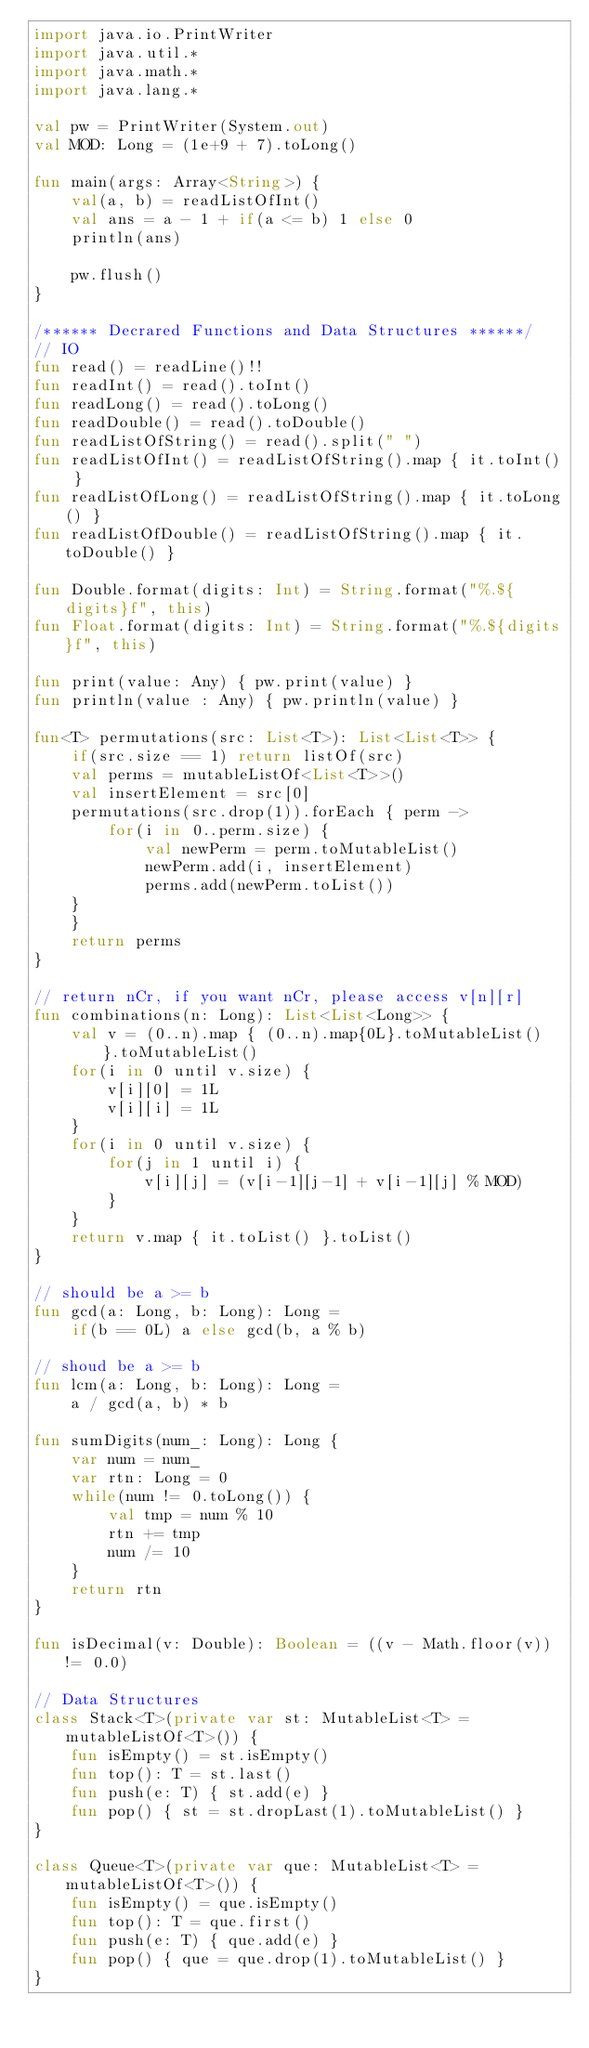Convert code to text. <code><loc_0><loc_0><loc_500><loc_500><_Kotlin_>import java.io.PrintWriter
import java.util.*
import java.math.*
import java.lang.*

val pw = PrintWriter(System.out)
val MOD: Long = (1e+9 + 7).toLong()

fun main(args: Array<String>) {
    val(a, b) = readListOfInt()
    val ans = a - 1 + if(a <= b) 1 else 0
    println(ans)
    
    pw.flush()
}

/****** Decrared Functions and Data Structures ******/
// IO
fun read() = readLine()!!
fun readInt() = read().toInt()
fun readLong() = read().toLong()
fun readDouble() = read().toDouble()
fun readListOfString() = read().split(" ")
fun readListOfInt() = readListOfString().map { it.toInt() }
fun readListOfLong() = readListOfString().map { it.toLong() }
fun readListOfDouble() = readListOfString().map { it.toDouble() }

fun Double.format(digits: Int) = String.format("%.${digits}f", this)
fun Float.format(digits: Int) = String.format("%.${digits}f", this)

fun print(value: Any) { pw.print(value) }
fun println(value : Any) { pw.println(value) }

fun<T> permutations(src: List<T>): List<List<T>> {
    if(src.size == 1) return listOf(src)
    val perms = mutableListOf<List<T>>()
    val insertElement = src[0]
    permutations(src.drop(1)).forEach { perm ->
        for(i in 0..perm.size) {
            val newPerm = perm.toMutableList()
            newPerm.add(i, insertElement)
            perms.add(newPerm.toList())
    }
    }
    return perms
}

// return nCr, if you want nCr, please access v[n][r]
fun combinations(n: Long): List<List<Long>> {
    val v = (0..n).map { (0..n).map{0L}.toMutableList() }.toMutableList()
    for(i in 0 until v.size) {
        v[i][0] = 1L
        v[i][i] = 1L
    }
    for(i in 0 until v.size) {
        for(j in 1 until i) {
            v[i][j] = (v[i-1][j-1] + v[i-1][j] % MOD)
        }
    }
    return v.map { it.toList() }.toList()
}

// should be a >= b
fun gcd(a: Long, b: Long): Long = 
    if(b == 0L) a else gcd(b, a % b)

// shoud be a >= b
fun lcm(a: Long, b: Long): Long = 
    a / gcd(a, b) * b

fun sumDigits(num_: Long): Long {
    var num = num_
    var rtn: Long = 0
    while(num != 0.toLong()) {
        val tmp = num % 10
        rtn += tmp
        num /= 10
    }
    return rtn
}

fun isDecimal(v: Double): Boolean = ((v - Math.floor(v)) != 0.0)

// Data Structures
class Stack<T>(private var st: MutableList<T> = mutableListOf<T>()) {
    fun isEmpty() = st.isEmpty()
    fun top(): T = st.last()
    fun push(e: T) { st.add(e) }
    fun pop() { st = st.dropLast(1).toMutableList() }
}

class Queue<T>(private var que: MutableList<T> = mutableListOf<T>()) {
    fun isEmpty() = que.isEmpty()
    fun top(): T = que.first()
    fun push(e: T) { que.add(e) }
    fun pop() { que = que.drop(1).toMutableList() }
}
</code> 